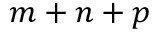<formula> <loc_0><loc_0><loc_500><loc_500>m + n + p</formula> 